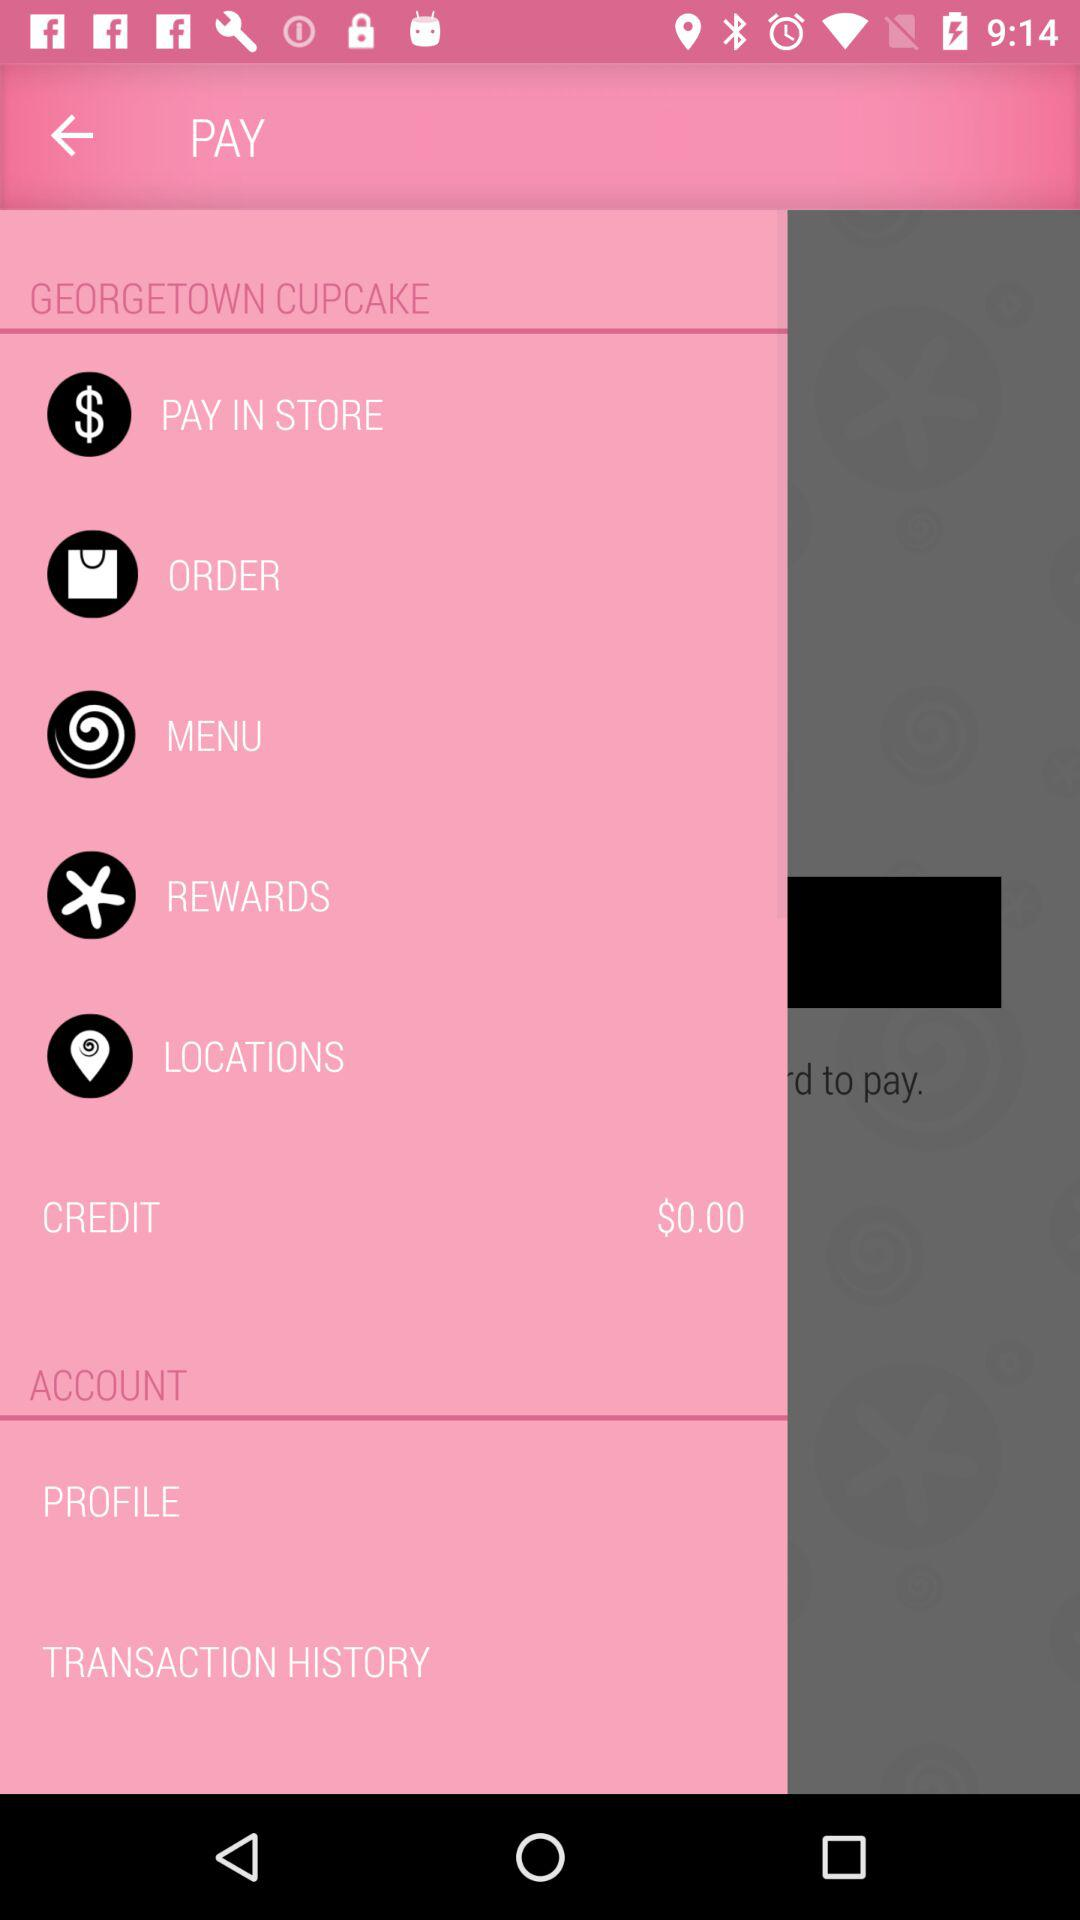How much is the total amount of money in the account?
Answer the question using a single word or phrase. $0.00 